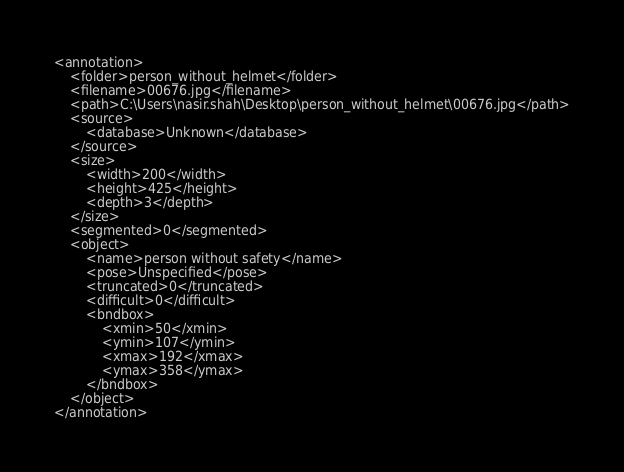Convert code to text. <code><loc_0><loc_0><loc_500><loc_500><_XML_><annotation>
	<folder>person_without_helmet</folder>
	<filename>00676.jpg</filename>
	<path>C:\Users\nasir.shah\Desktop\person_without_helmet\00676.jpg</path>
	<source>
		<database>Unknown</database>
	</source>
	<size>
		<width>200</width>
		<height>425</height>
		<depth>3</depth>
	</size>
	<segmented>0</segmented>
	<object>
		<name>person without safety</name>
		<pose>Unspecified</pose>
		<truncated>0</truncated>
		<difficult>0</difficult>
		<bndbox>
			<xmin>50</xmin>
			<ymin>107</ymin>
			<xmax>192</xmax>
			<ymax>358</ymax>
		</bndbox>
	</object>
</annotation></code> 